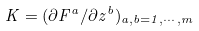Convert formula to latex. <formula><loc_0><loc_0><loc_500><loc_500>K = ( \partial F ^ { a } / \partial z ^ { b } ) _ { a , b = 1 , \cdots , m }</formula> 